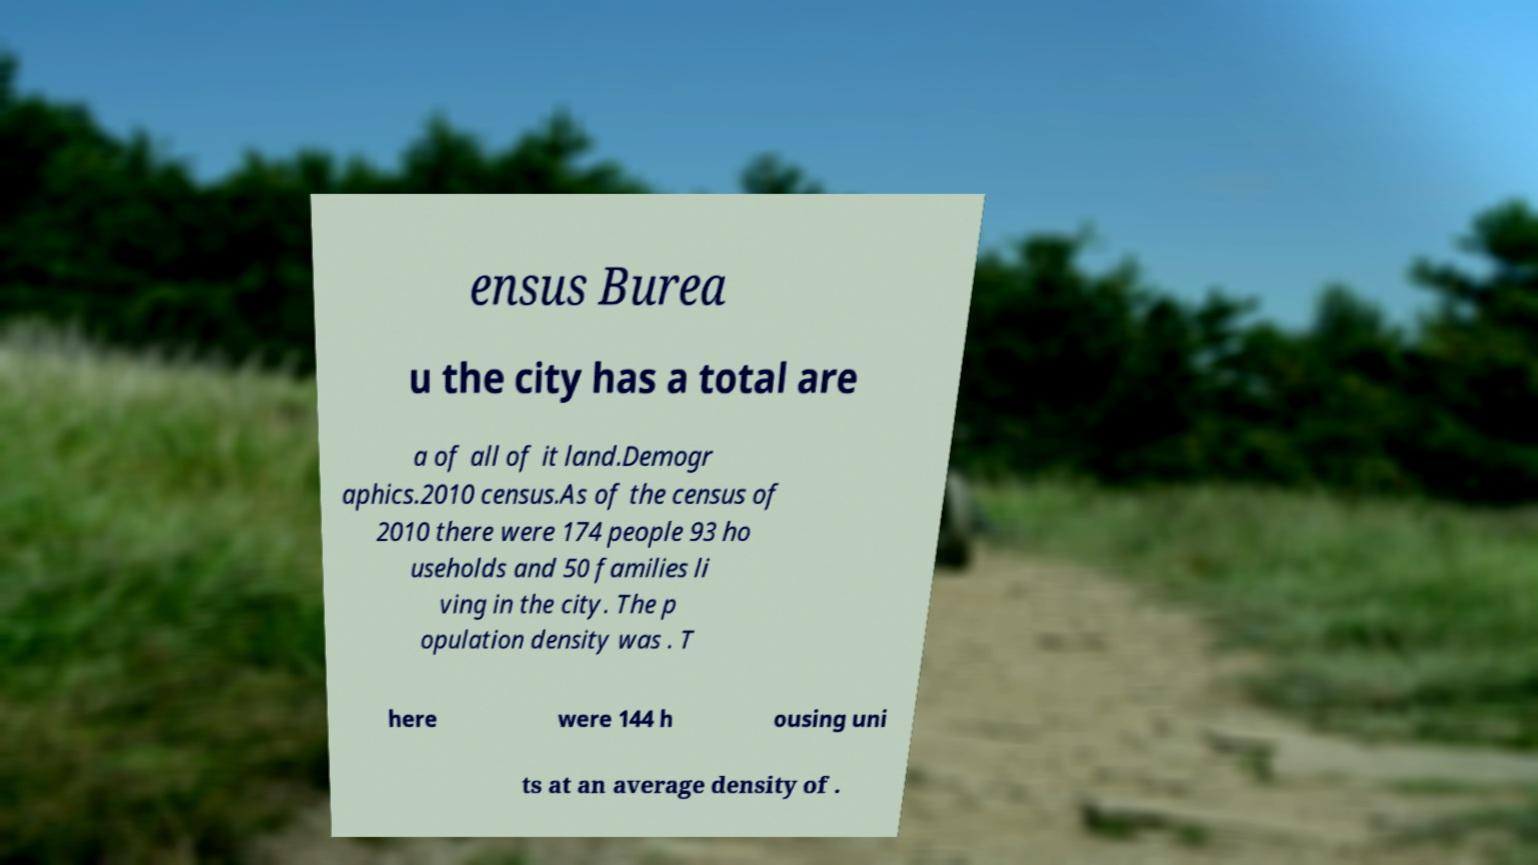Could you extract and type out the text from this image? ensus Burea u the city has a total are a of all of it land.Demogr aphics.2010 census.As of the census of 2010 there were 174 people 93 ho useholds and 50 families li ving in the city. The p opulation density was . T here were 144 h ousing uni ts at an average density of . 